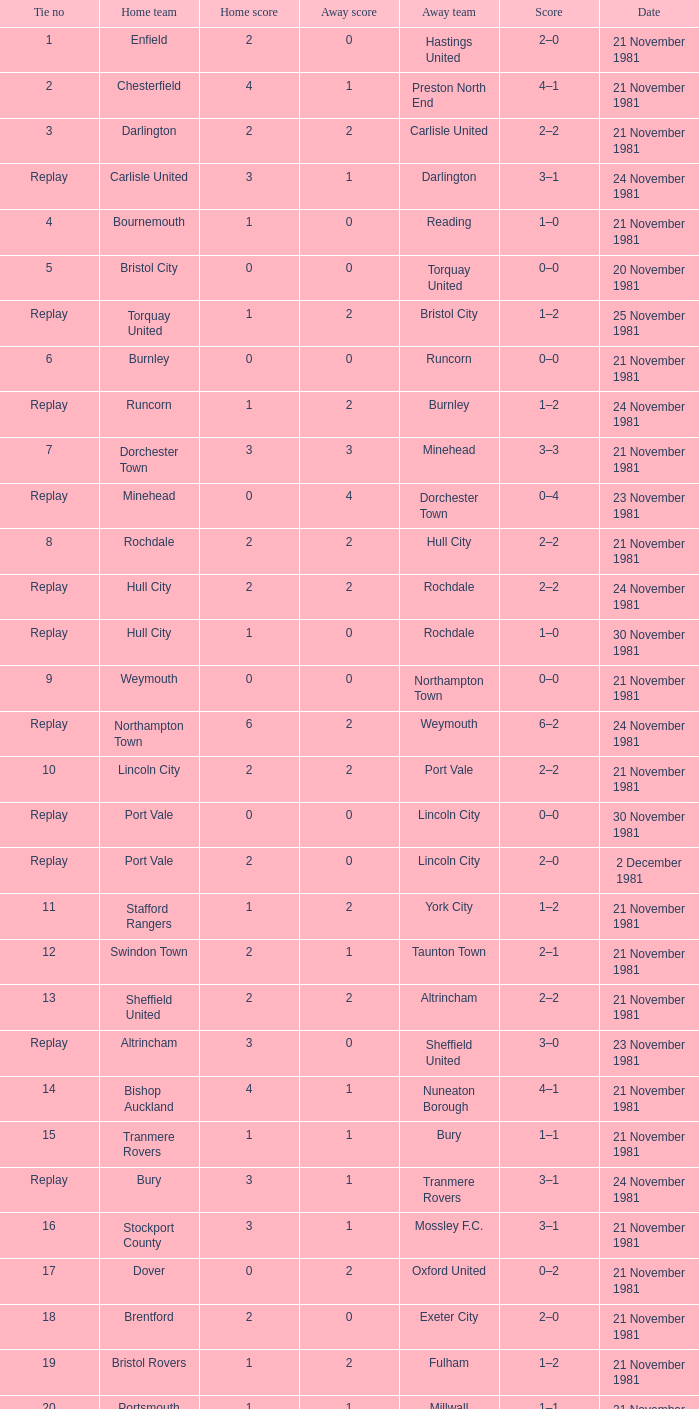What number is associated with minehead's tie? Replay. 